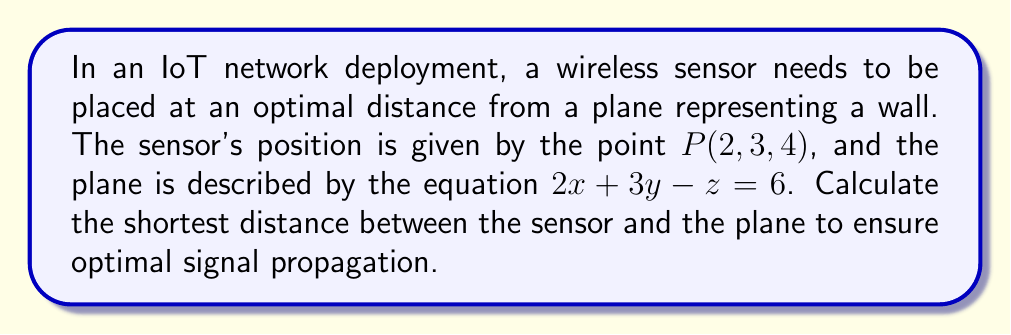Show me your answer to this math problem. To find the shortest distance between a point and a plane in 3D space, we can use the formula:

$$ d = \frac{|Ax_0 + By_0 + Cz_0 + D|}{\sqrt{A^2 + B^2 + C^2}} $$

Where $(x_0, y_0, z_0)$ is the point, and $Ax + By + Cz + D = 0$ is the equation of the plane.

Step 1: Identify the components from the given information:
- Point $P(x_0, y_0, z_0) = (2, 3, 4)$
- Plane equation: $2x + 3y - z = 6$, which can be rewritten as $2x + 3y - z - 6 = 0$

Step 2: Match the plane equation to the standard form $Ax + By + Cz + D = 0$:
$A = 2$, $B = 3$, $C = -1$, $D = -6$

Step 3: Substitute the values into the distance formula:

$$ d = \frac{|2(2) + 3(3) + (-1)(4) + (-6)|}{\sqrt{2^2 + 3^2 + (-1)^2}} $$

Step 4: Simplify the numerator:
$$ d = \frac{|4 + 9 - 4 - 6|}{\sqrt{4 + 9 + 1}} = \frac{|3|}{\sqrt{14}} $$

Step 5: Simplify the final expression:
$$ d = \frac{3}{\sqrt{14}} $$

This distance represents the optimal placement of the sensor from the plane for efficient signal propagation in the IoT network.
Answer: $\frac{3}{\sqrt{14}}$ 